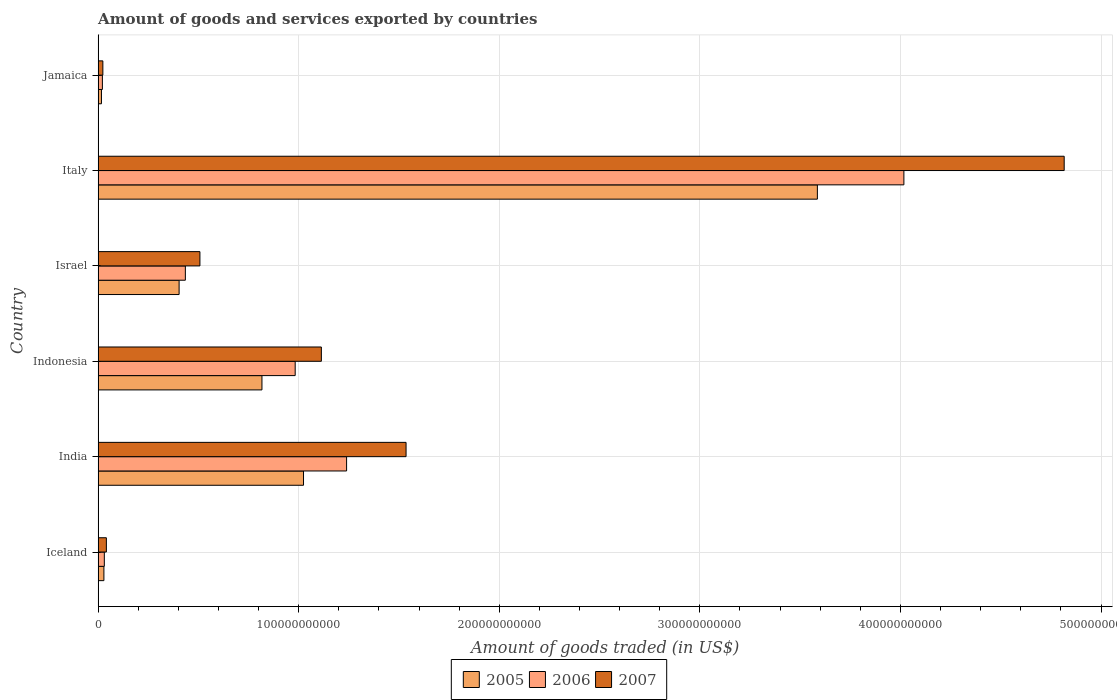Are the number of bars on each tick of the Y-axis equal?
Keep it short and to the point. Yes. How many bars are there on the 2nd tick from the top?
Keep it short and to the point. 3. How many bars are there on the 5th tick from the bottom?
Your answer should be very brief. 3. In how many cases, is the number of bars for a given country not equal to the number of legend labels?
Keep it short and to the point. 0. What is the total amount of goods and services exported in 2005 in India?
Your response must be concise. 1.02e+11. Across all countries, what is the maximum total amount of goods and services exported in 2007?
Ensure brevity in your answer.  4.82e+11. Across all countries, what is the minimum total amount of goods and services exported in 2005?
Keep it short and to the point. 1.66e+09. In which country was the total amount of goods and services exported in 2005 maximum?
Your answer should be compact. Italy. In which country was the total amount of goods and services exported in 2006 minimum?
Your answer should be compact. Jamaica. What is the total total amount of goods and services exported in 2006 in the graph?
Ensure brevity in your answer.  6.73e+11. What is the difference between the total amount of goods and services exported in 2007 in India and that in Indonesia?
Make the answer very short. 4.22e+1. What is the difference between the total amount of goods and services exported in 2007 in Italy and the total amount of goods and services exported in 2005 in Indonesia?
Offer a very short reply. 4.00e+11. What is the average total amount of goods and services exported in 2006 per country?
Provide a short and direct response. 1.12e+11. What is the difference between the total amount of goods and services exported in 2007 and total amount of goods and services exported in 2006 in India?
Your answer should be very brief. 2.97e+1. In how many countries, is the total amount of goods and services exported in 2005 greater than 440000000000 US$?
Make the answer very short. 0. What is the ratio of the total amount of goods and services exported in 2007 in Indonesia to that in Israel?
Give a very brief answer. 2.19. Is the total amount of goods and services exported in 2005 in Israel less than that in Italy?
Provide a succinct answer. Yes. What is the difference between the highest and the second highest total amount of goods and services exported in 2006?
Keep it short and to the point. 2.78e+11. What is the difference between the highest and the lowest total amount of goods and services exported in 2007?
Make the answer very short. 4.79e+11. What does the 1st bar from the bottom in Jamaica represents?
Give a very brief answer. 2005. Are all the bars in the graph horizontal?
Offer a very short reply. Yes. What is the difference between two consecutive major ticks on the X-axis?
Offer a terse response. 1.00e+11. Does the graph contain grids?
Ensure brevity in your answer.  Yes. How are the legend labels stacked?
Keep it short and to the point. Horizontal. What is the title of the graph?
Give a very brief answer. Amount of goods and services exported by countries. What is the label or title of the X-axis?
Offer a terse response. Amount of goods traded (in US$). What is the Amount of goods traded (in US$) in 2005 in Iceland?
Give a very brief answer. 2.89e+09. What is the Amount of goods traded (in US$) of 2006 in Iceland?
Provide a short and direct response. 3.10e+09. What is the Amount of goods traded (in US$) in 2007 in Iceland?
Keep it short and to the point. 4.12e+09. What is the Amount of goods traded (in US$) of 2005 in India?
Your answer should be very brief. 1.02e+11. What is the Amount of goods traded (in US$) of 2006 in India?
Keep it short and to the point. 1.24e+11. What is the Amount of goods traded (in US$) of 2007 in India?
Keep it short and to the point. 1.54e+11. What is the Amount of goods traded (in US$) of 2005 in Indonesia?
Provide a short and direct response. 8.17e+1. What is the Amount of goods traded (in US$) in 2006 in Indonesia?
Ensure brevity in your answer.  9.83e+1. What is the Amount of goods traded (in US$) in 2007 in Indonesia?
Your answer should be compact. 1.11e+11. What is the Amount of goods traded (in US$) in 2005 in Israel?
Offer a terse response. 4.04e+1. What is the Amount of goods traded (in US$) in 2006 in Israel?
Your answer should be very brief. 4.35e+1. What is the Amount of goods traded (in US$) in 2007 in Israel?
Make the answer very short. 5.08e+1. What is the Amount of goods traded (in US$) of 2005 in Italy?
Your response must be concise. 3.59e+11. What is the Amount of goods traded (in US$) of 2006 in Italy?
Provide a short and direct response. 4.02e+11. What is the Amount of goods traded (in US$) in 2007 in Italy?
Ensure brevity in your answer.  4.82e+11. What is the Amount of goods traded (in US$) of 2005 in Jamaica?
Ensure brevity in your answer.  1.66e+09. What is the Amount of goods traded (in US$) in 2006 in Jamaica?
Ensure brevity in your answer.  2.13e+09. What is the Amount of goods traded (in US$) in 2007 in Jamaica?
Keep it short and to the point. 2.36e+09. Across all countries, what is the maximum Amount of goods traded (in US$) of 2005?
Offer a very short reply. 3.59e+11. Across all countries, what is the maximum Amount of goods traded (in US$) of 2006?
Give a very brief answer. 4.02e+11. Across all countries, what is the maximum Amount of goods traded (in US$) of 2007?
Keep it short and to the point. 4.82e+11. Across all countries, what is the minimum Amount of goods traded (in US$) of 2005?
Your answer should be very brief. 1.66e+09. Across all countries, what is the minimum Amount of goods traded (in US$) in 2006?
Provide a succinct answer. 2.13e+09. Across all countries, what is the minimum Amount of goods traded (in US$) in 2007?
Offer a very short reply. 2.36e+09. What is the total Amount of goods traded (in US$) of 2005 in the graph?
Offer a terse response. 5.88e+11. What is the total Amount of goods traded (in US$) in 2006 in the graph?
Ensure brevity in your answer.  6.73e+11. What is the total Amount of goods traded (in US$) of 2007 in the graph?
Your answer should be compact. 8.04e+11. What is the difference between the Amount of goods traded (in US$) of 2005 in Iceland and that in India?
Give a very brief answer. -9.95e+1. What is the difference between the Amount of goods traded (in US$) in 2006 in Iceland and that in India?
Ensure brevity in your answer.  -1.21e+11. What is the difference between the Amount of goods traded (in US$) of 2007 in Iceland and that in India?
Your answer should be very brief. -1.49e+11. What is the difference between the Amount of goods traded (in US$) in 2005 in Iceland and that in Indonesia?
Your answer should be compact. -7.88e+1. What is the difference between the Amount of goods traded (in US$) in 2006 in Iceland and that in Indonesia?
Offer a terse response. -9.52e+1. What is the difference between the Amount of goods traded (in US$) of 2007 in Iceland and that in Indonesia?
Give a very brief answer. -1.07e+11. What is the difference between the Amount of goods traded (in US$) of 2005 in Iceland and that in Israel?
Your answer should be compact. -3.75e+1. What is the difference between the Amount of goods traded (in US$) of 2006 in Iceland and that in Israel?
Your response must be concise. -4.04e+1. What is the difference between the Amount of goods traded (in US$) of 2007 in Iceland and that in Israel?
Give a very brief answer. -4.66e+1. What is the difference between the Amount of goods traded (in US$) in 2005 in Iceland and that in Italy?
Provide a short and direct response. -3.56e+11. What is the difference between the Amount of goods traded (in US$) of 2006 in Iceland and that in Italy?
Offer a terse response. -3.99e+11. What is the difference between the Amount of goods traded (in US$) in 2007 in Iceland and that in Italy?
Provide a short and direct response. -4.78e+11. What is the difference between the Amount of goods traded (in US$) in 2005 in Iceland and that in Jamaica?
Provide a succinct answer. 1.22e+09. What is the difference between the Amount of goods traded (in US$) in 2006 in Iceland and that in Jamaica?
Your answer should be very brief. 9.65e+08. What is the difference between the Amount of goods traded (in US$) of 2007 in Iceland and that in Jamaica?
Your answer should be very brief. 1.76e+09. What is the difference between the Amount of goods traded (in US$) of 2005 in India and that in Indonesia?
Provide a succinct answer. 2.07e+1. What is the difference between the Amount of goods traded (in US$) of 2006 in India and that in Indonesia?
Ensure brevity in your answer.  2.56e+1. What is the difference between the Amount of goods traded (in US$) of 2007 in India and that in Indonesia?
Your answer should be very brief. 4.22e+1. What is the difference between the Amount of goods traded (in US$) of 2005 in India and that in Israel?
Offer a very short reply. 6.20e+1. What is the difference between the Amount of goods traded (in US$) of 2006 in India and that in Israel?
Keep it short and to the point. 8.04e+1. What is the difference between the Amount of goods traded (in US$) in 2007 in India and that in Israel?
Your response must be concise. 1.03e+11. What is the difference between the Amount of goods traded (in US$) of 2005 in India and that in Italy?
Your response must be concise. -2.56e+11. What is the difference between the Amount of goods traded (in US$) of 2006 in India and that in Italy?
Ensure brevity in your answer.  -2.78e+11. What is the difference between the Amount of goods traded (in US$) in 2007 in India and that in Italy?
Ensure brevity in your answer.  -3.28e+11. What is the difference between the Amount of goods traded (in US$) of 2005 in India and that in Jamaica?
Your response must be concise. 1.01e+11. What is the difference between the Amount of goods traded (in US$) of 2006 in India and that in Jamaica?
Provide a short and direct response. 1.22e+11. What is the difference between the Amount of goods traded (in US$) of 2007 in India and that in Jamaica?
Offer a very short reply. 1.51e+11. What is the difference between the Amount of goods traded (in US$) of 2005 in Indonesia and that in Israel?
Give a very brief answer. 4.13e+1. What is the difference between the Amount of goods traded (in US$) in 2006 in Indonesia and that in Israel?
Provide a short and direct response. 5.48e+1. What is the difference between the Amount of goods traded (in US$) in 2007 in Indonesia and that in Israel?
Ensure brevity in your answer.  6.05e+1. What is the difference between the Amount of goods traded (in US$) of 2005 in Indonesia and that in Italy?
Keep it short and to the point. -2.77e+11. What is the difference between the Amount of goods traded (in US$) of 2006 in Indonesia and that in Italy?
Ensure brevity in your answer.  -3.03e+11. What is the difference between the Amount of goods traded (in US$) in 2007 in Indonesia and that in Italy?
Make the answer very short. -3.70e+11. What is the difference between the Amount of goods traded (in US$) in 2005 in Indonesia and that in Jamaica?
Provide a short and direct response. 8.00e+1. What is the difference between the Amount of goods traded (in US$) of 2006 in Indonesia and that in Jamaica?
Ensure brevity in your answer.  9.61e+1. What is the difference between the Amount of goods traded (in US$) of 2007 in Indonesia and that in Jamaica?
Make the answer very short. 1.09e+11. What is the difference between the Amount of goods traded (in US$) in 2005 in Israel and that in Italy?
Ensure brevity in your answer.  -3.18e+11. What is the difference between the Amount of goods traded (in US$) of 2006 in Israel and that in Italy?
Your answer should be compact. -3.58e+11. What is the difference between the Amount of goods traded (in US$) of 2007 in Israel and that in Italy?
Your answer should be very brief. -4.31e+11. What is the difference between the Amount of goods traded (in US$) of 2005 in Israel and that in Jamaica?
Your response must be concise. 3.87e+1. What is the difference between the Amount of goods traded (in US$) in 2006 in Israel and that in Jamaica?
Offer a terse response. 4.14e+1. What is the difference between the Amount of goods traded (in US$) in 2007 in Israel and that in Jamaica?
Keep it short and to the point. 4.84e+1. What is the difference between the Amount of goods traded (in US$) of 2005 in Italy and that in Jamaica?
Provide a short and direct response. 3.57e+11. What is the difference between the Amount of goods traded (in US$) of 2006 in Italy and that in Jamaica?
Make the answer very short. 4.00e+11. What is the difference between the Amount of goods traded (in US$) of 2007 in Italy and that in Jamaica?
Ensure brevity in your answer.  4.79e+11. What is the difference between the Amount of goods traded (in US$) of 2005 in Iceland and the Amount of goods traded (in US$) of 2006 in India?
Keep it short and to the point. -1.21e+11. What is the difference between the Amount of goods traded (in US$) in 2005 in Iceland and the Amount of goods traded (in US$) in 2007 in India?
Your answer should be very brief. -1.51e+11. What is the difference between the Amount of goods traded (in US$) in 2006 in Iceland and the Amount of goods traded (in US$) in 2007 in India?
Give a very brief answer. -1.50e+11. What is the difference between the Amount of goods traded (in US$) of 2005 in Iceland and the Amount of goods traded (in US$) of 2006 in Indonesia?
Provide a short and direct response. -9.54e+1. What is the difference between the Amount of goods traded (in US$) in 2005 in Iceland and the Amount of goods traded (in US$) in 2007 in Indonesia?
Keep it short and to the point. -1.08e+11. What is the difference between the Amount of goods traded (in US$) in 2006 in Iceland and the Amount of goods traded (in US$) in 2007 in Indonesia?
Your answer should be very brief. -1.08e+11. What is the difference between the Amount of goods traded (in US$) of 2005 in Iceland and the Amount of goods traded (in US$) of 2006 in Israel?
Offer a terse response. -4.06e+1. What is the difference between the Amount of goods traded (in US$) of 2005 in Iceland and the Amount of goods traded (in US$) of 2007 in Israel?
Provide a short and direct response. -4.79e+1. What is the difference between the Amount of goods traded (in US$) of 2006 in Iceland and the Amount of goods traded (in US$) of 2007 in Israel?
Your answer should be compact. -4.77e+1. What is the difference between the Amount of goods traded (in US$) of 2005 in Iceland and the Amount of goods traded (in US$) of 2006 in Italy?
Ensure brevity in your answer.  -3.99e+11. What is the difference between the Amount of goods traded (in US$) in 2005 in Iceland and the Amount of goods traded (in US$) in 2007 in Italy?
Your answer should be compact. -4.79e+11. What is the difference between the Amount of goods traded (in US$) in 2006 in Iceland and the Amount of goods traded (in US$) in 2007 in Italy?
Keep it short and to the point. -4.79e+11. What is the difference between the Amount of goods traded (in US$) of 2005 in Iceland and the Amount of goods traded (in US$) of 2006 in Jamaica?
Provide a short and direct response. 7.52e+08. What is the difference between the Amount of goods traded (in US$) in 2005 in Iceland and the Amount of goods traded (in US$) in 2007 in Jamaica?
Offer a terse response. 5.23e+08. What is the difference between the Amount of goods traded (in US$) of 2006 in Iceland and the Amount of goods traded (in US$) of 2007 in Jamaica?
Ensure brevity in your answer.  7.36e+08. What is the difference between the Amount of goods traded (in US$) in 2005 in India and the Amount of goods traded (in US$) in 2006 in Indonesia?
Offer a terse response. 4.15e+09. What is the difference between the Amount of goods traded (in US$) of 2005 in India and the Amount of goods traded (in US$) of 2007 in Indonesia?
Give a very brief answer. -8.90e+09. What is the difference between the Amount of goods traded (in US$) of 2006 in India and the Amount of goods traded (in US$) of 2007 in Indonesia?
Provide a short and direct response. 1.26e+1. What is the difference between the Amount of goods traded (in US$) in 2005 in India and the Amount of goods traded (in US$) in 2006 in Israel?
Provide a short and direct response. 5.89e+1. What is the difference between the Amount of goods traded (in US$) in 2005 in India and the Amount of goods traded (in US$) in 2007 in Israel?
Your answer should be compact. 5.16e+1. What is the difference between the Amount of goods traded (in US$) of 2006 in India and the Amount of goods traded (in US$) of 2007 in Israel?
Give a very brief answer. 7.31e+1. What is the difference between the Amount of goods traded (in US$) in 2005 in India and the Amount of goods traded (in US$) in 2006 in Italy?
Provide a short and direct response. -2.99e+11. What is the difference between the Amount of goods traded (in US$) of 2005 in India and the Amount of goods traded (in US$) of 2007 in Italy?
Ensure brevity in your answer.  -3.79e+11. What is the difference between the Amount of goods traded (in US$) of 2006 in India and the Amount of goods traded (in US$) of 2007 in Italy?
Make the answer very short. -3.58e+11. What is the difference between the Amount of goods traded (in US$) of 2005 in India and the Amount of goods traded (in US$) of 2006 in Jamaica?
Give a very brief answer. 1.00e+11. What is the difference between the Amount of goods traded (in US$) of 2005 in India and the Amount of goods traded (in US$) of 2007 in Jamaica?
Give a very brief answer. 1.00e+11. What is the difference between the Amount of goods traded (in US$) in 2006 in India and the Amount of goods traded (in US$) in 2007 in Jamaica?
Your response must be concise. 1.22e+11. What is the difference between the Amount of goods traded (in US$) of 2005 in Indonesia and the Amount of goods traded (in US$) of 2006 in Israel?
Your answer should be compact. 3.82e+1. What is the difference between the Amount of goods traded (in US$) in 2005 in Indonesia and the Amount of goods traded (in US$) in 2007 in Israel?
Offer a very short reply. 3.09e+1. What is the difference between the Amount of goods traded (in US$) in 2006 in Indonesia and the Amount of goods traded (in US$) in 2007 in Israel?
Provide a succinct answer. 4.75e+1. What is the difference between the Amount of goods traded (in US$) of 2005 in Indonesia and the Amount of goods traded (in US$) of 2006 in Italy?
Make the answer very short. -3.20e+11. What is the difference between the Amount of goods traded (in US$) of 2005 in Indonesia and the Amount of goods traded (in US$) of 2007 in Italy?
Ensure brevity in your answer.  -4.00e+11. What is the difference between the Amount of goods traded (in US$) in 2006 in Indonesia and the Amount of goods traded (in US$) in 2007 in Italy?
Your response must be concise. -3.83e+11. What is the difference between the Amount of goods traded (in US$) of 2005 in Indonesia and the Amount of goods traded (in US$) of 2006 in Jamaica?
Your response must be concise. 7.95e+1. What is the difference between the Amount of goods traded (in US$) in 2005 in Indonesia and the Amount of goods traded (in US$) in 2007 in Jamaica?
Give a very brief answer. 7.93e+1. What is the difference between the Amount of goods traded (in US$) in 2006 in Indonesia and the Amount of goods traded (in US$) in 2007 in Jamaica?
Your answer should be very brief. 9.59e+1. What is the difference between the Amount of goods traded (in US$) of 2005 in Israel and the Amount of goods traded (in US$) of 2006 in Italy?
Offer a terse response. -3.61e+11. What is the difference between the Amount of goods traded (in US$) of 2005 in Israel and the Amount of goods traded (in US$) of 2007 in Italy?
Give a very brief answer. -4.41e+11. What is the difference between the Amount of goods traded (in US$) of 2006 in Israel and the Amount of goods traded (in US$) of 2007 in Italy?
Keep it short and to the point. -4.38e+11. What is the difference between the Amount of goods traded (in US$) of 2005 in Israel and the Amount of goods traded (in US$) of 2006 in Jamaica?
Provide a short and direct response. 3.82e+1. What is the difference between the Amount of goods traded (in US$) of 2005 in Israel and the Amount of goods traded (in US$) of 2007 in Jamaica?
Your answer should be very brief. 3.80e+1. What is the difference between the Amount of goods traded (in US$) in 2006 in Israel and the Amount of goods traded (in US$) in 2007 in Jamaica?
Provide a succinct answer. 4.11e+1. What is the difference between the Amount of goods traded (in US$) of 2005 in Italy and the Amount of goods traded (in US$) of 2006 in Jamaica?
Provide a succinct answer. 3.56e+11. What is the difference between the Amount of goods traded (in US$) of 2005 in Italy and the Amount of goods traded (in US$) of 2007 in Jamaica?
Your response must be concise. 3.56e+11. What is the difference between the Amount of goods traded (in US$) of 2006 in Italy and the Amount of goods traded (in US$) of 2007 in Jamaica?
Provide a short and direct response. 3.99e+11. What is the average Amount of goods traded (in US$) in 2005 per country?
Keep it short and to the point. 9.79e+1. What is the average Amount of goods traded (in US$) of 2006 per country?
Your response must be concise. 1.12e+11. What is the average Amount of goods traded (in US$) of 2007 per country?
Provide a short and direct response. 1.34e+11. What is the difference between the Amount of goods traded (in US$) in 2005 and Amount of goods traded (in US$) in 2006 in Iceland?
Ensure brevity in your answer.  -2.13e+08. What is the difference between the Amount of goods traded (in US$) of 2005 and Amount of goods traded (in US$) of 2007 in Iceland?
Make the answer very short. -1.23e+09. What is the difference between the Amount of goods traded (in US$) in 2006 and Amount of goods traded (in US$) in 2007 in Iceland?
Ensure brevity in your answer.  -1.02e+09. What is the difference between the Amount of goods traded (in US$) of 2005 and Amount of goods traded (in US$) of 2006 in India?
Provide a succinct answer. -2.15e+1. What is the difference between the Amount of goods traded (in US$) of 2005 and Amount of goods traded (in US$) of 2007 in India?
Ensure brevity in your answer.  -5.11e+1. What is the difference between the Amount of goods traded (in US$) in 2006 and Amount of goods traded (in US$) in 2007 in India?
Provide a short and direct response. -2.97e+1. What is the difference between the Amount of goods traded (in US$) in 2005 and Amount of goods traded (in US$) in 2006 in Indonesia?
Make the answer very short. -1.66e+1. What is the difference between the Amount of goods traded (in US$) of 2005 and Amount of goods traded (in US$) of 2007 in Indonesia?
Your answer should be very brief. -2.96e+1. What is the difference between the Amount of goods traded (in US$) in 2006 and Amount of goods traded (in US$) in 2007 in Indonesia?
Provide a short and direct response. -1.31e+1. What is the difference between the Amount of goods traded (in US$) in 2005 and Amount of goods traded (in US$) in 2006 in Israel?
Your answer should be compact. -3.12e+09. What is the difference between the Amount of goods traded (in US$) of 2005 and Amount of goods traded (in US$) of 2007 in Israel?
Provide a succinct answer. -1.04e+1. What is the difference between the Amount of goods traded (in US$) in 2006 and Amount of goods traded (in US$) in 2007 in Israel?
Offer a very short reply. -7.27e+09. What is the difference between the Amount of goods traded (in US$) in 2005 and Amount of goods traded (in US$) in 2006 in Italy?
Provide a short and direct response. -4.31e+1. What is the difference between the Amount of goods traded (in US$) in 2005 and Amount of goods traded (in US$) in 2007 in Italy?
Give a very brief answer. -1.23e+11. What is the difference between the Amount of goods traded (in US$) in 2006 and Amount of goods traded (in US$) in 2007 in Italy?
Your answer should be compact. -7.99e+1. What is the difference between the Amount of goods traded (in US$) of 2005 and Amount of goods traded (in US$) of 2006 in Jamaica?
Offer a terse response. -4.69e+08. What is the difference between the Amount of goods traded (in US$) of 2005 and Amount of goods traded (in US$) of 2007 in Jamaica?
Provide a short and direct response. -6.98e+08. What is the difference between the Amount of goods traded (in US$) of 2006 and Amount of goods traded (in US$) of 2007 in Jamaica?
Provide a short and direct response. -2.29e+08. What is the ratio of the Amount of goods traded (in US$) in 2005 in Iceland to that in India?
Your answer should be compact. 0.03. What is the ratio of the Amount of goods traded (in US$) in 2006 in Iceland to that in India?
Ensure brevity in your answer.  0.03. What is the ratio of the Amount of goods traded (in US$) of 2007 in Iceland to that in India?
Keep it short and to the point. 0.03. What is the ratio of the Amount of goods traded (in US$) of 2005 in Iceland to that in Indonesia?
Your answer should be compact. 0.04. What is the ratio of the Amount of goods traded (in US$) in 2006 in Iceland to that in Indonesia?
Provide a short and direct response. 0.03. What is the ratio of the Amount of goods traded (in US$) in 2007 in Iceland to that in Indonesia?
Offer a terse response. 0.04. What is the ratio of the Amount of goods traded (in US$) in 2005 in Iceland to that in Israel?
Your answer should be compact. 0.07. What is the ratio of the Amount of goods traded (in US$) in 2006 in Iceland to that in Israel?
Offer a very short reply. 0.07. What is the ratio of the Amount of goods traded (in US$) of 2007 in Iceland to that in Israel?
Provide a succinct answer. 0.08. What is the ratio of the Amount of goods traded (in US$) of 2005 in Iceland to that in Italy?
Make the answer very short. 0.01. What is the ratio of the Amount of goods traded (in US$) in 2006 in Iceland to that in Italy?
Ensure brevity in your answer.  0.01. What is the ratio of the Amount of goods traded (in US$) in 2007 in Iceland to that in Italy?
Your answer should be compact. 0.01. What is the ratio of the Amount of goods traded (in US$) in 2005 in Iceland to that in Jamaica?
Provide a succinct answer. 1.73. What is the ratio of the Amount of goods traded (in US$) of 2006 in Iceland to that in Jamaica?
Your answer should be very brief. 1.45. What is the ratio of the Amount of goods traded (in US$) of 2007 in Iceland to that in Jamaica?
Your response must be concise. 1.74. What is the ratio of the Amount of goods traded (in US$) in 2005 in India to that in Indonesia?
Provide a short and direct response. 1.25. What is the ratio of the Amount of goods traded (in US$) of 2006 in India to that in Indonesia?
Your answer should be compact. 1.26. What is the ratio of the Amount of goods traded (in US$) in 2007 in India to that in Indonesia?
Keep it short and to the point. 1.38. What is the ratio of the Amount of goods traded (in US$) in 2005 in India to that in Israel?
Your response must be concise. 2.54. What is the ratio of the Amount of goods traded (in US$) of 2006 in India to that in Israel?
Ensure brevity in your answer.  2.85. What is the ratio of the Amount of goods traded (in US$) in 2007 in India to that in Israel?
Keep it short and to the point. 3.02. What is the ratio of the Amount of goods traded (in US$) in 2005 in India to that in Italy?
Ensure brevity in your answer.  0.29. What is the ratio of the Amount of goods traded (in US$) in 2006 in India to that in Italy?
Keep it short and to the point. 0.31. What is the ratio of the Amount of goods traded (in US$) of 2007 in India to that in Italy?
Provide a short and direct response. 0.32. What is the ratio of the Amount of goods traded (in US$) in 2005 in India to that in Jamaica?
Your answer should be very brief. 61.53. What is the ratio of the Amount of goods traded (in US$) in 2006 in India to that in Jamaica?
Keep it short and to the point. 58.06. What is the ratio of the Amount of goods traded (in US$) of 2007 in India to that in Jamaica?
Your answer should be compact. 64.98. What is the ratio of the Amount of goods traded (in US$) in 2005 in Indonesia to that in Israel?
Provide a short and direct response. 2.02. What is the ratio of the Amount of goods traded (in US$) in 2006 in Indonesia to that in Israel?
Provide a succinct answer. 2.26. What is the ratio of the Amount of goods traded (in US$) of 2007 in Indonesia to that in Israel?
Provide a short and direct response. 2.19. What is the ratio of the Amount of goods traded (in US$) in 2005 in Indonesia to that in Italy?
Make the answer very short. 0.23. What is the ratio of the Amount of goods traded (in US$) in 2006 in Indonesia to that in Italy?
Provide a succinct answer. 0.24. What is the ratio of the Amount of goods traded (in US$) in 2007 in Indonesia to that in Italy?
Your answer should be very brief. 0.23. What is the ratio of the Amount of goods traded (in US$) of 2005 in Indonesia to that in Jamaica?
Give a very brief answer. 49.08. What is the ratio of the Amount of goods traded (in US$) in 2006 in Indonesia to that in Jamaica?
Provide a succinct answer. 46.05. What is the ratio of the Amount of goods traded (in US$) of 2007 in Indonesia to that in Jamaica?
Offer a very short reply. 47.11. What is the ratio of the Amount of goods traded (in US$) of 2005 in Israel to that in Italy?
Your response must be concise. 0.11. What is the ratio of the Amount of goods traded (in US$) of 2006 in Israel to that in Italy?
Offer a terse response. 0.11. What is the ratio of the Amount of goods traded (in US$) of 2007 in Israel to that in Italy?
Provide a succinct answer. 0.11. What is the ratio of the Amount of goods traded (in US$) of 2005 in Israel to that in Jamaica?
Offer a very short reply. 24.26. What is the ratio of the Amount of goods traded (in US$) of 2006 in Israel to that in Jamaica?
Offer a terse response. 20.38. What is the ratio of the Amount of goods traded (in US$) in 2007 in Israel to that in Jamaica?
Your response must be concise. 21.48. What is the ratio of the Amount of goods traded (in US$) of 2005 in Italy to that in Jamaica?
Offer a very short reply. 215.46. What is the ratio of the Amount of goods traded (in US$) in 2006 in Italy to that in Jamaica?
Your answer should be compact. 188.28. What is the ratio of the Amount of goods traded (in US$) of 2007 in Italy to that in Jamaica?
Your answer should be very brief. 203.86. What is the difference between the highest and the second highest Amount of goods traded (in US$) of 2005?
Provide a succinct answer. 2.56e+11. What is the difference between the highest and the second highest Amount of goods traded (in US$) of 2006?
Your answer should be compact. 2.78e+11. What is the difference between the highest and the second highest Amount of goods traded (in US$) of 2007?
Give a very brief answer. 3.28e+11. What is the difference between the highest and the lowest Amount of goods traded (in US$) of 2005?
Ensure brevity in your answer.  3.57e+11. What is the difference between the highest and the lowest Amount of goods traded (in US$) of 2006?
Ensure brevity in your answer.  4.00e+11. What is the difference between the highest and the lowest Amount of goods traded (in US$) in 2007?
Offer a very short reply. 4.79e+11. 